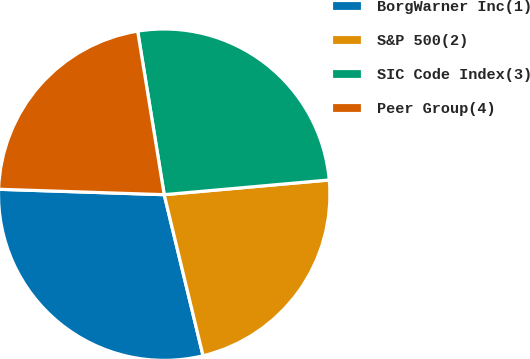Convert chart. <chart><loc_0><loc_0><loc_500><loc_500><pie_chart><fcel>BorgWarner Inc(1)<fcel>S&P 500(2)<fcel>SIC Code Index(3)<fcel>Peer Group(4)<nl><fcel>29.29%<fcel>22.65%<fcel>26.15%<fcel>21.92%<nl></chart> 